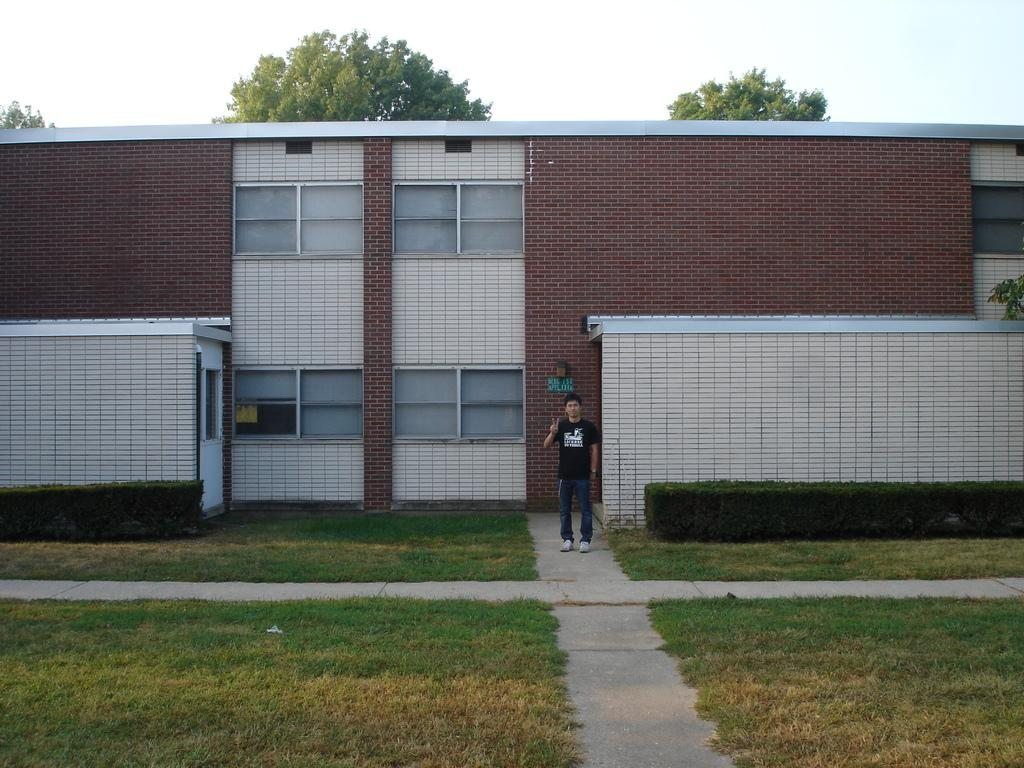What is the main subject of the image? There is a person in the image. What is the person wearing? The person is wearing a black T-shirt. What type of natural environment is visible in the image? There is grass visible in the image. Can you describe the building in the image? There is a brick building with glass windows in the image. What can be seen in the background of the image? Trees and the sky are visible in the background of the image. What type of hose can be seen watering the potato plants in the image? There is no hose or potato plants present in the image. What kind of jewel is the person wearing on their wrist in the image? There is no jewel visible on the person's wrist in the image. 